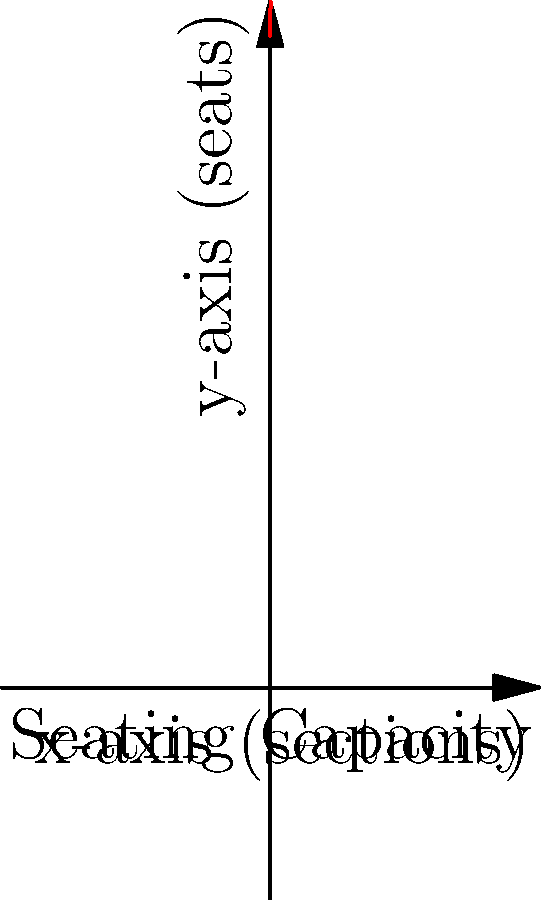As a 49ers fan, you're curious about the seating capacity of Levi's Stadium. The stadium's seating arrangement can be modeled by the polynomial function $f(x) = -0.1x^3 + 1.5x^2 + 100x + 20000$, where $x$ represents the number of sections and $f(x)$ represents the total number of seats. If the stadium has 10 sections, what is the approximate total seating capacity? Let's approach this step-by-step:

1) We're given the polynomial function: 
   $f(x) = -0.1x^3 + 1.5x^2 + 100x + 20000$

2) We need to find $f(10)$, as the stadium has 10 sections.

3) Let's substitute $x = 10$ into the function:
   $f(10) = -0.1(10)^3 + 1.5(10)^2 + 100(10) + 20000$

4) Now, let's calculate each term:
   - $-0.1(10)^3 = -0.1(1000) = -100$
   - $1.5(10)^2 = 1.5(100) = 150$
   - $100(10) = 1000$
   - $20000$ remains as is

5) Adding these terms:
   $f(10) = -100 + 150 + 1000 + 20000 = 21050$

Therefore, the approximate seating capacity of the stadium with 10 sections is 21,050 seats.
Answer: 21,050 seats 